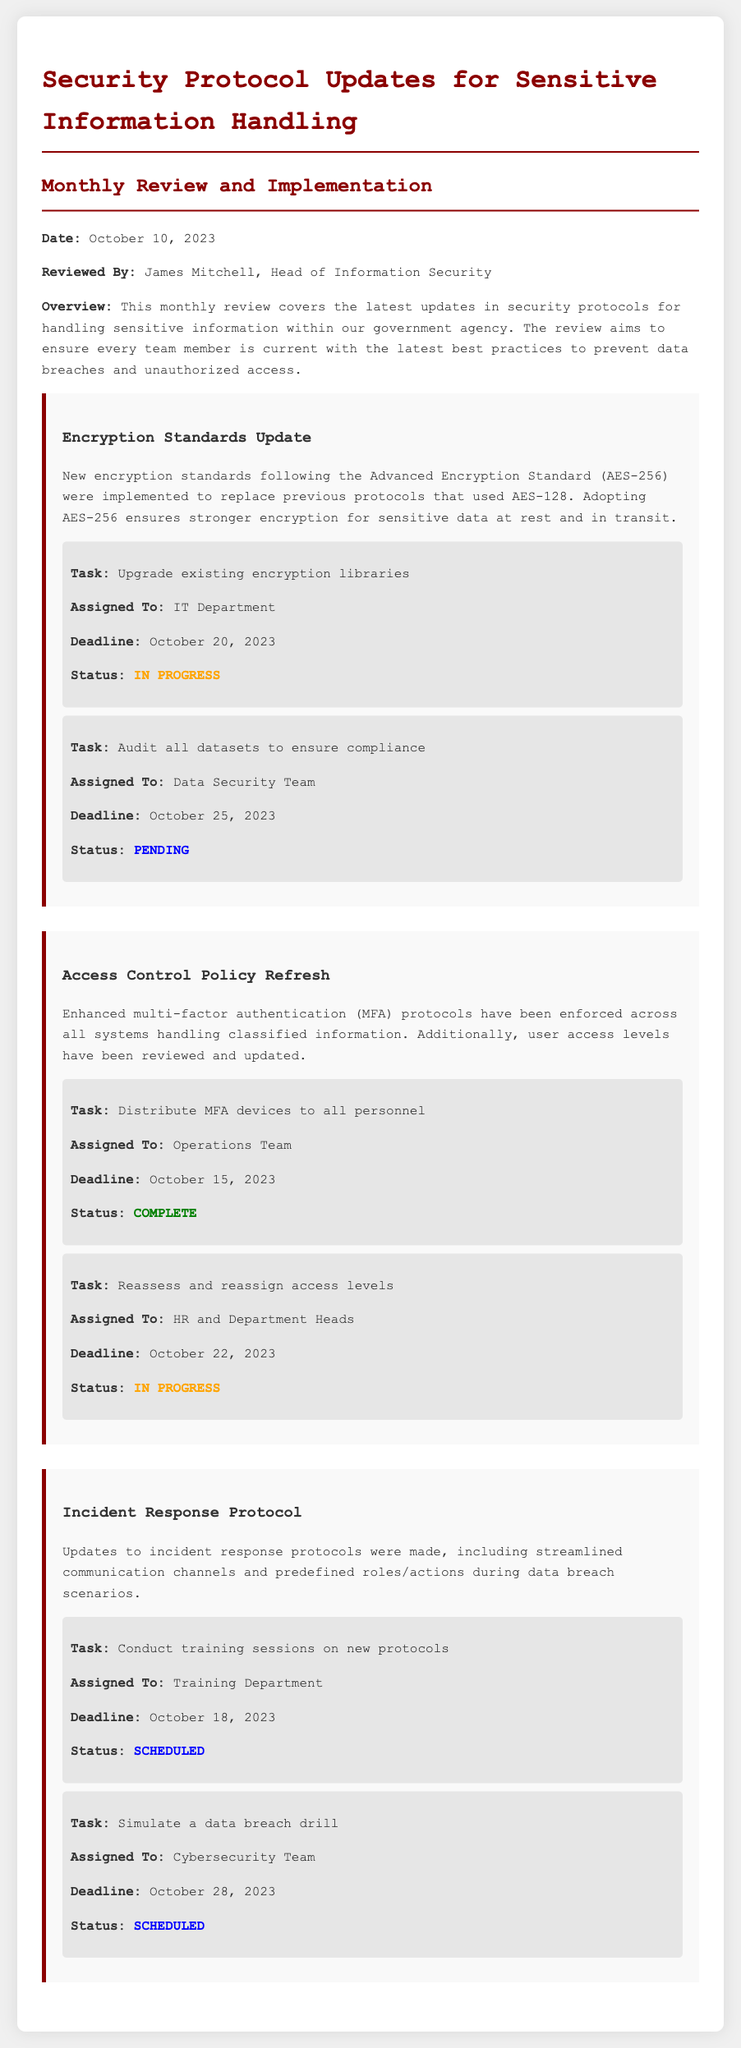What is the date of the review? The document states that the review date is specifically mentioned at the beginning of the log.
Answer: October 10, 2023 Who reviewed the document? The "Reviewed By" section clearly names the individual responsible for the review.
Answer: James Mitchell What is the new encryption standard implemented? The document specifies the encryption standard adopted in the updates concerning sensitive information.
Answer: AES-256 What is the deadline for upgrading encryption libraries? The deadline for this specific task is provided in the action items related to encryption standards.
Answer: October 20, 2023 Which team is responsible for distributing MFA devices? The action items section indicates the team assigned this particular task.
Answer: Operations Team What is the status of the task to conduct training sessions on new protocols? The document includes the status of each action item, which shows how far along the task is.
Answer: Scheduled What tasks are pending according to the log? The document lists the tasks with their specific statuses, allowing us to identify which are still not completed.
Answer: Audit all datasets to ensure compliance How many tasks are scheduled for completion after October 20, 2023? The document provides details on all tasks, including their deadlines, enabling us to determine how many are scheduled.
Answer: Two What was added to the incident response protocol? The overview of modifications to the incident response protocols includes specific enhancements and actions taken.
Answer: Streamlined communication channels 